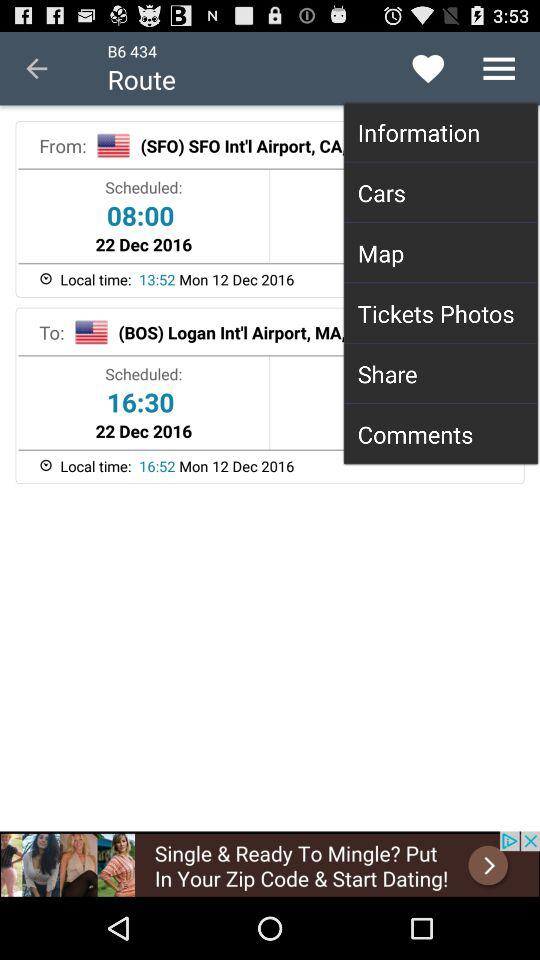What is the scheduled date? The scheduled date is December 22, 2016. 